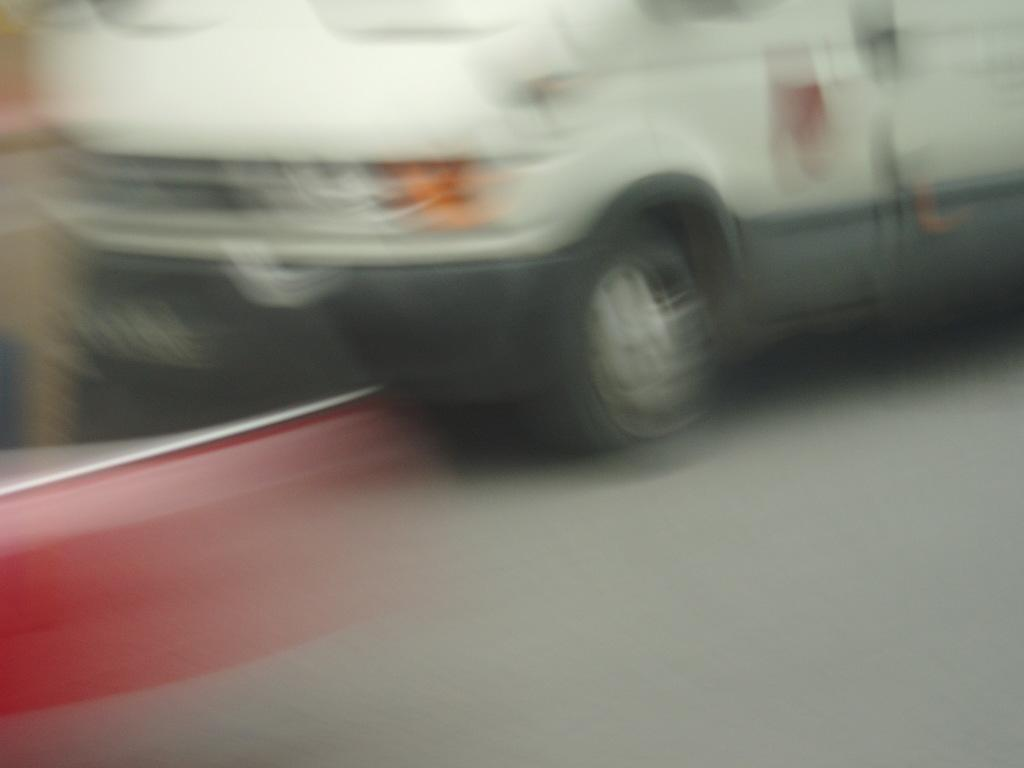What is the overall quality of the image? The image is blurry. Can you identify any specific objects or subjects in the image? There is a vehicle passing by, but due to the blurriness, no specific details about the vehicle can be extracted. What type of mint is growing in the image? There is no mint present in the image, as it only features a blurry vehicle passing by. Is there a book visible in the image? No, there is no book visible in the image; it only features a blurry vehicle passing by. 